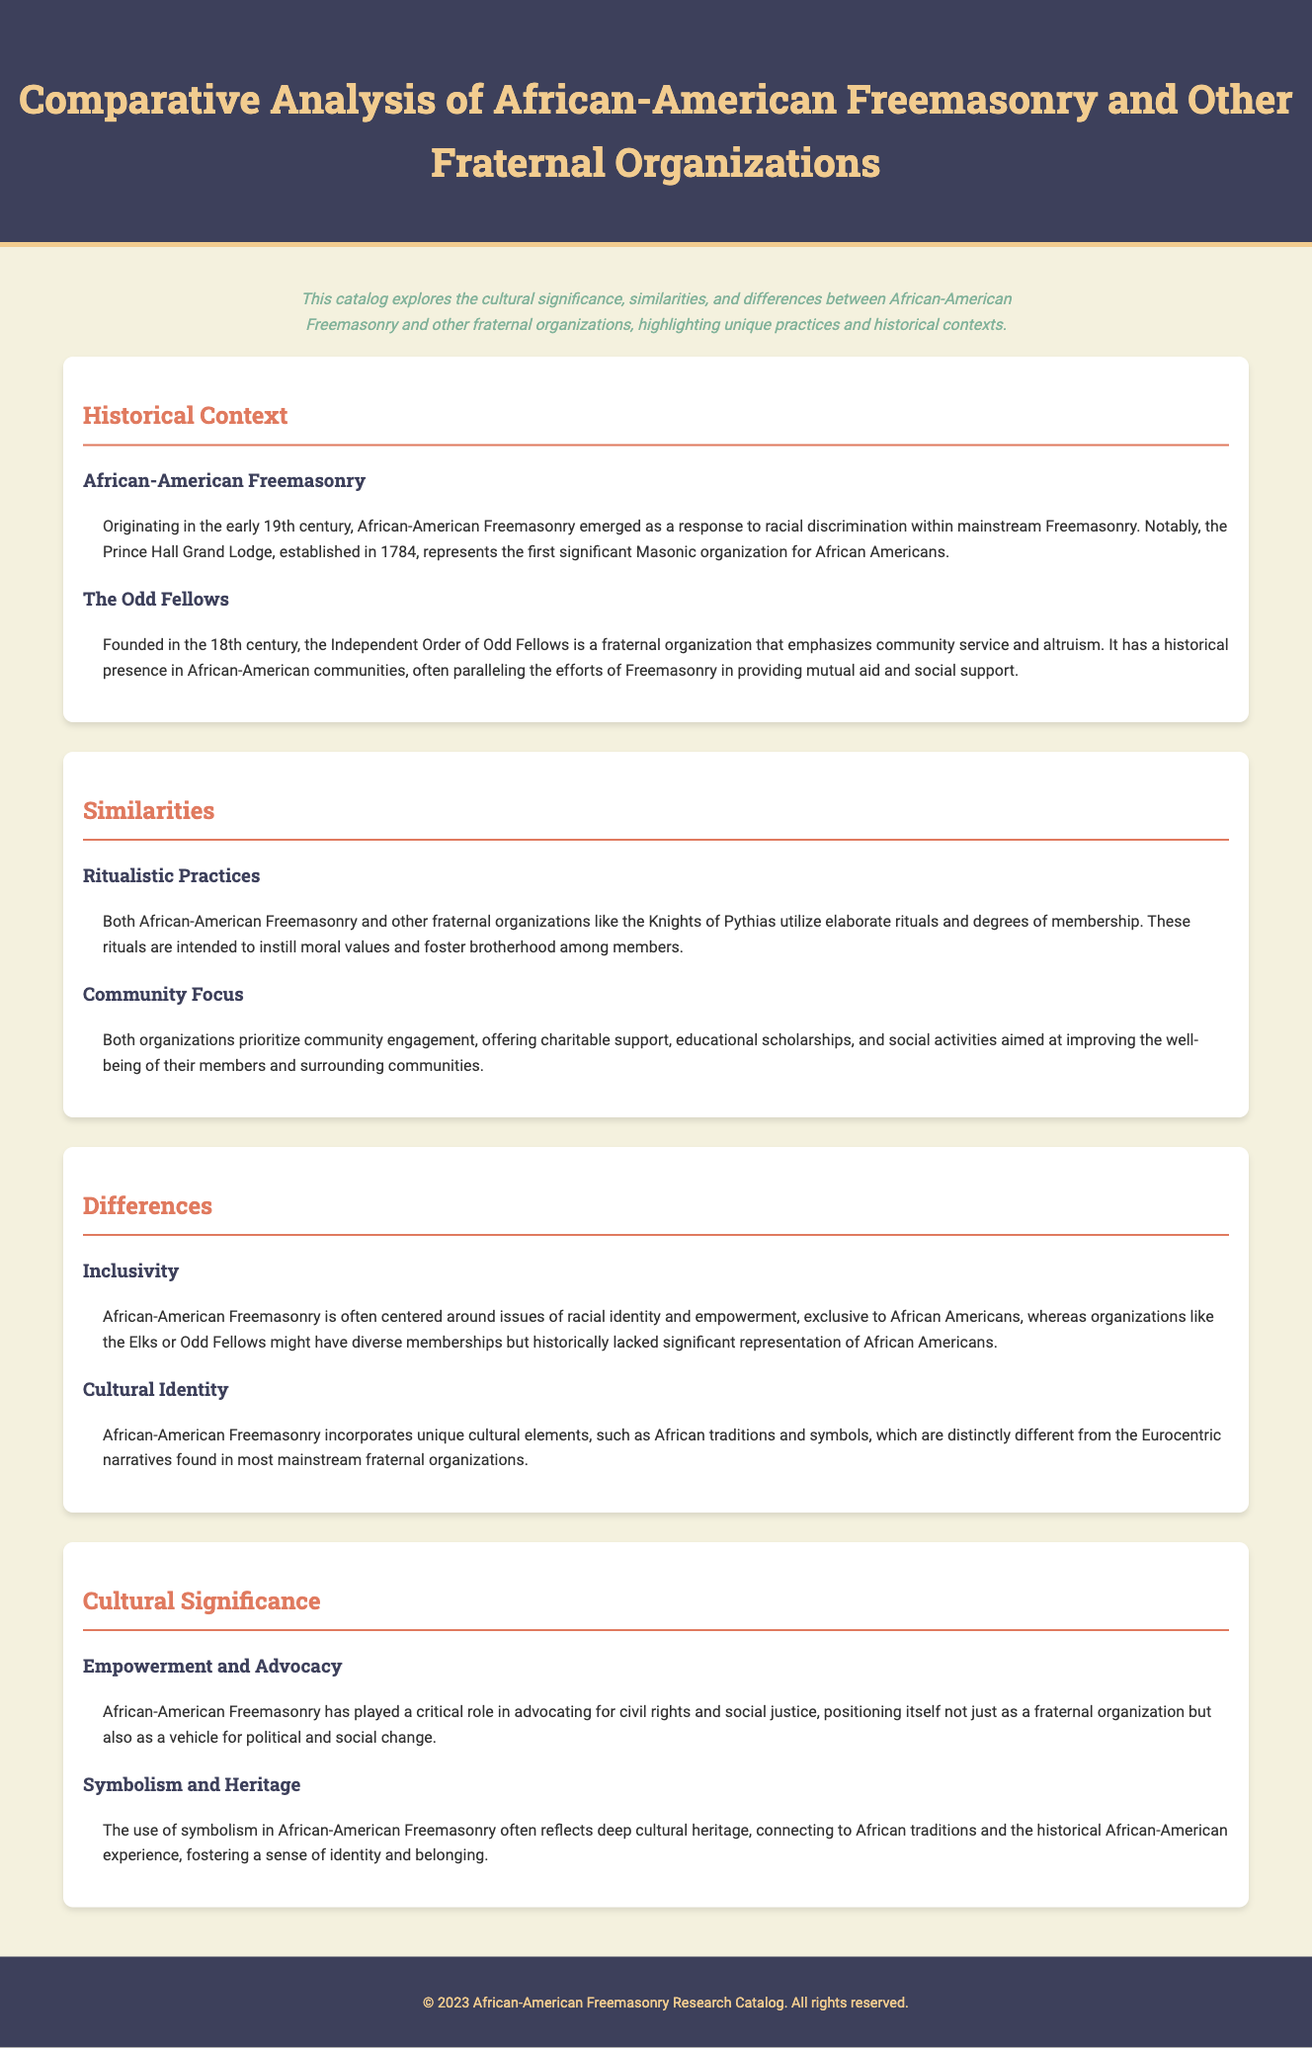What year was the Prince Hall Grand Lodge established? The Prince Hall Grand Lodge was established in 1784, as mentioned in the historical context of African-American Freemasonry.
Answer: 1784 What is a significant focus of the Odd Fellows? The Odd Fellows emphasize community service and altruism, which is noted in their historical context within the document.
Answer: Community service Which fraternal organization utilizes elaborate rituals like African-American Freemasonry? The Knights of Pythias is mentioned as a fraternal organization that also uses elaborate rituals and degrees of membership.
Answer: Knights of Pythias How does African-American Freemasonry differentiate in terms of membership? African-American Freemasonry is exclusive to African Americans, unlike other organizations that might have diverse memberships.
Answer: Exclusive to African Americans What role does African-American Freemasonry play in social justice? African-American Freemasonry advocates for civil rights and social justice, positioning itself as a vehicle for political change.
Answer: Advocacy for civil rights What cultural elements are incorporated into African-American Freemasonry? African-American Freemasonry incorporates African traditions and symbols that reflect its distinct cultural identity.
Answer: African traditions and symbols What is one of the community-focused activities of both African-American Freemasonry and other fraternal organizations? Charitable support is mentioned as a priority for both African-American Freemasonry and other organizations.
Answer: Charitable support 